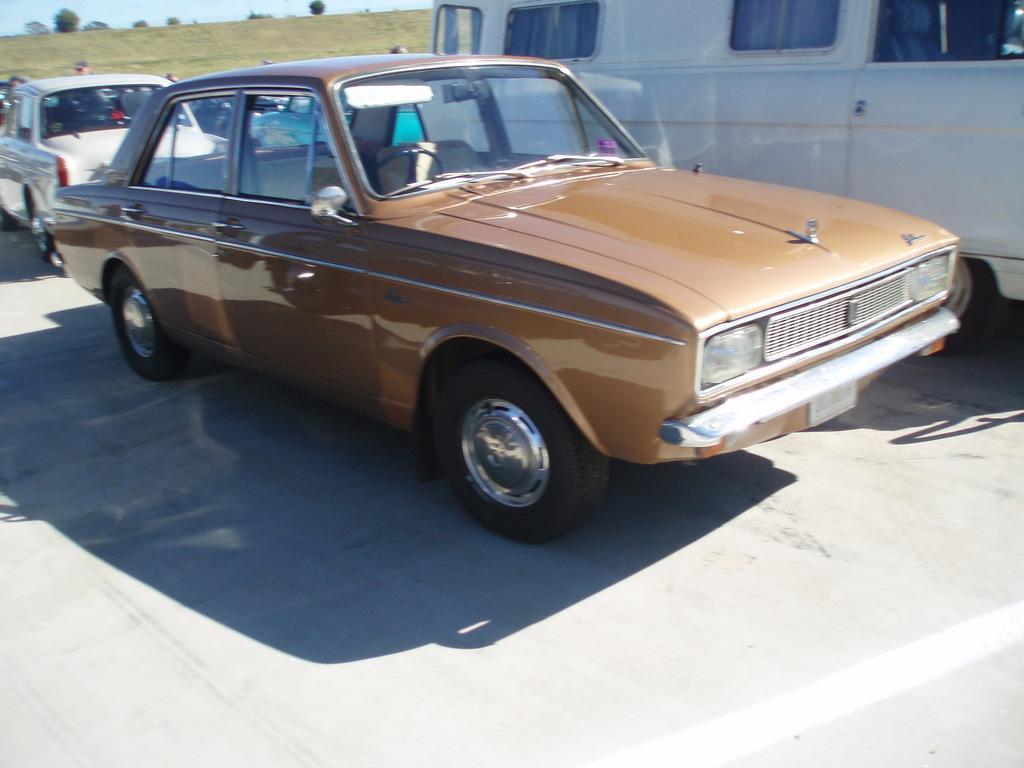Describe this image in one or two sentences. In this image there are vehicles, people in the foreground. There are trees and grass in the background. There is sky at the top. And there is road at the bottom. 